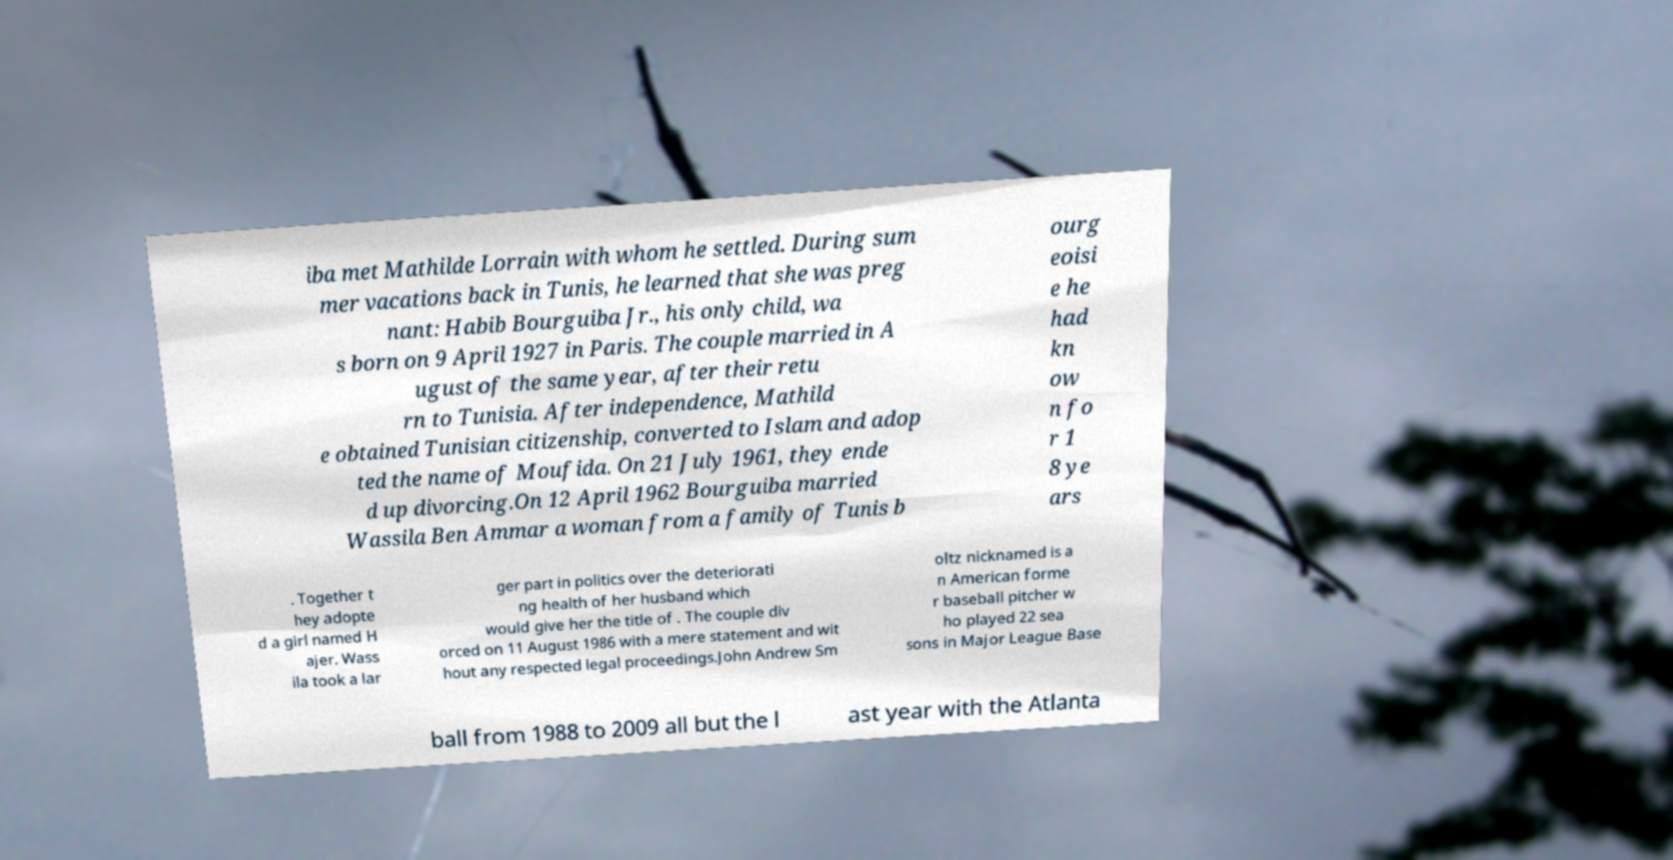Can you read and provide the text displayed in the image?This photo seems to have some interesting text. Can you extract and type it out for me? iba met Mathilde Lorrain with whom he settled. During sum mer vacations back in Tunis, he learned that she was preg nant: Habib Bourguiba Jr., his only child, wa s born on 9 April 1927 in Paris. The couple married in A ugust of the same year, after their retu rn to Tunisia. After independence, Mathild e obtained Tunisian citizenship, converted to Islam and adop ted the name of Moufida. On 21 July 1961, they ende d up divorcing.On 12 April 1962 Bourguiba married Wassila Ben Ammar a woman from a family of Tunis b ourg eoisi e he had kn ow n fo r 1 8 ye ars . Together t hey adopte d a girl named H ajer. Wass ila took a lar ger part in politics over the deteriorati ng health of her husband which would give her the title of . The couple div orced on 11 August 1986 with a mere statement and wit hout any respected legal proceedings.John Andrew Sm oltz nicknamed is a n American forme r baseball pitcher w ho played 22 sea sons in Major League Base ball from 1988 to 2009 all but the l ast year with the Atlanta 